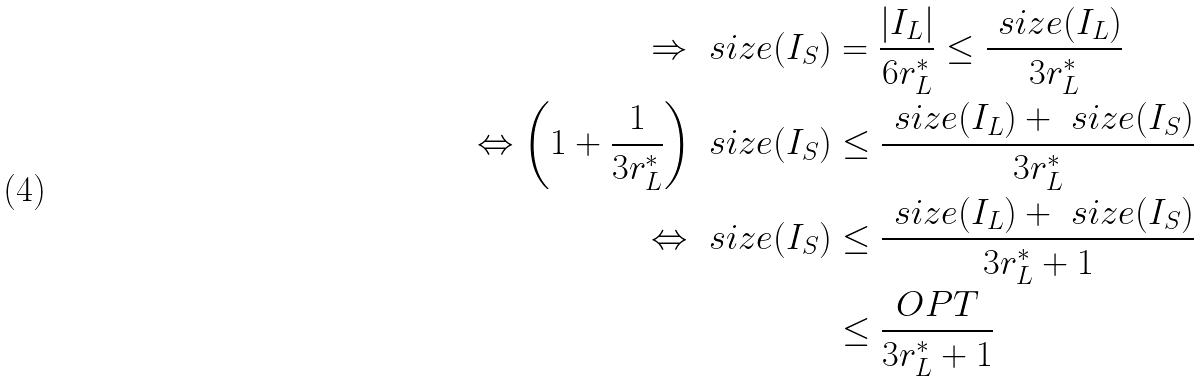Convert formula to latex. <formula><loc_0><loc_0><loc_500><loc_500>\Rightarrow \ s i z e ( I _ { S } ) & = \frac { | I _ { L } | } { 6 r _ { L } ^ { * } } \leq \frac { \ s i z e ( I _ { L } ) } { 3 r _ { L } ^ { * } } \\ \Leftrightarrow \left ( 1 + \frac { 1 } { 3 r _ { L } ^ { * } } \right ) \ s i z e ( I _ { S } ) & \leq \frac { \ s i z e ( I _ { L } ) + \ s i z e ( I _ { S } ) } { 3 r _ { L } ^ { * } } \\ \Leftrightarrow \ s i z e ( I _ { S } ) & \leq \frac { \ s i z e ( I _ { L } ) + \ s i z e ( I _ { S } ) } { 3 r _ { L } ^ { * } + 1 } \\ & \leq \frac { O P T } { 3 r _ { L } ^ { * } + 1 }</formula> 